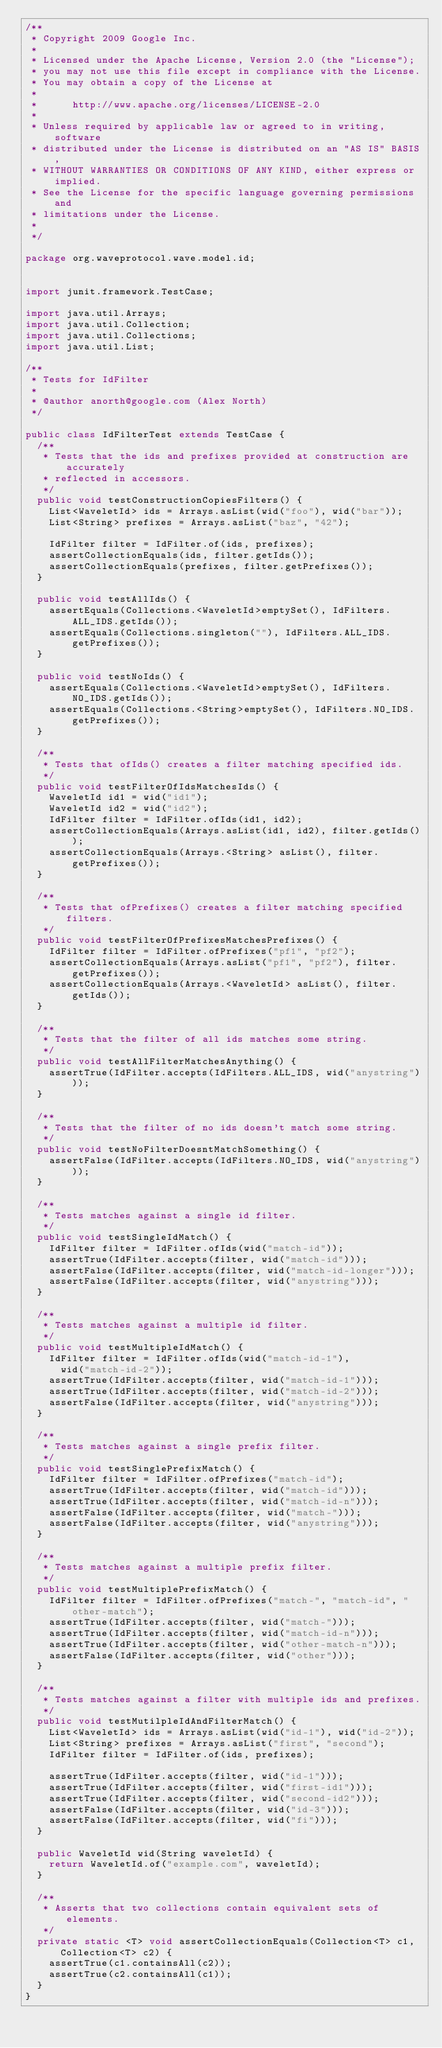<code> <loc_0><loc_0><loc_500><loc_500><_Java_>/**
 * Copyright 2009 Google Inc.
 *
 * Licensed under the Apache License, Version 2.0 (the "License");
 * you may not use this file except in compliance with the License.
 * You may obtain a copy of the License at
 *
 *      http://www.apache.org/licenses/LICENSE-2.0
 *
 * Unless required by applicable law or agreed to in writing, software
 * distributed under the License is distributed on an "AS IS" BASIS,
 * WITHOUT WARRANTIES OR CONDITIONS OF ANY KIND, either express or implied.
 * See the License for the specific language governing permissions and
 * limitations under the License.
 *
 */

package org.waveprotocol.wave.model.id;


import junit.framework.TestCase;

import java.util.Arrays;
import java.util.Collection;
import java.util.Collections;
import java.util.List;

/**
 * Tests for IdFilter
 *
 * @author anorth@google.com (Alex North)
 */

public class IdFilterTest extends TestCase {
  /**
   * Tests that the ids and prefixes provided at construction are accurately
   * reflected in accessors.
   */
  public void testConstructionCopiesFilters() {
    List<WaveletId> ids = Arrays.asList(wid("foo"), wid("bar"));
    List<String> prefixes = Arrays.asList("baz", "42");

    IdFilter filter = IdFilter.of(ids, prefixes);
    assertCollectionEquals(ids, filter.getIds());
    assertCollectionEquals(prefixes, filter.getPrefixes());
  }

  public void testAllIds() {
    assertEquals(Collections.<WaveletId>emptySet(), IdFilters.ALL_IDS.getIds());
    assertEquals(Collections.singleton(""), IdFilters.ALL_IDS.getPrefixes());
  }

  public void testNoIds() {
    assertEquals(Collections.<WaveletId>emptySet(), IdFilters.NO_IDS.getIds());
    assertEquals(Collections.<String>emptySet(), IdFilters.NO_IDS.getPrefixes());
  }

  /**
   * Tests that ofIds() creates a filter matching specified ids.
   */
  public void testFilterOfIdsMatchesIds() {
    WaveletId id1 = wid("id1");
    WaveletId id2 = wid("id2");
    IdFilter filter = IdFilter.ofIds(id1, id2);
    assertCollectionEquals(Arrays.asList(id1, id2), filter.getIds());
    assertCollectionEquals(Arrays.<String> asList(), filter.getPrefixes());
  }

  /**
   * Tests that ofPrefixes() creates a filter matching specified filters.
   */
  public void testFilterOfPrefixesMatchesPrefixes() {
    IdFilter filter = IdFilter.ofPrefixes("pf1", "pf2");
    assertCollectionEquals(Arrays.asList("pf1", "pf2"), filter.getPrefixes());
    assertCollectionEquals(Arrays.<WaveletId> asList(), filter.getIds());
  }

  /**
   * Tests that the filter of all ids matches some string.
   */
  public void testAllFilterMatchesAnything() {
    assertTrue(IdFilter.accepts(IdFilters.ALL_IDS, wid("anystring")));
  }

  /**
   * Tests that the filter of no ids doesn't match some string.
   */
  public void testNoFilterDoesntMatchSomething() {
    assertFalse(IdFilter.accepts(IdFilters.NO_IDS, wid("anystring")));
  }

  /**
   * Tests matches against a single id filter.
   */
  public void testSingleIdMatch() {
    IdFilter filter = IdFilter.ofIds(wid("match-id"));
    assertTrue(IdFilter.accepts(filter, wid("match-id")));
    assertFalse(IdFilter.accepts(filter, wid("match-id-longer")));
    assertFalse(IdFilter.accepts(filter, wid("anystring")));
  }

  /**
   * Tests matches against a multiple id filter.
   */
  public void testMultipleIdMatch() {
    IdFilter filter = IdFilter.ofIds(wid("match-id-1"),
      wid("match-id-2"));
    assertTrue(IdFilter.accepts(filter, wid("match-id-1")));
    assertTrue(IdFilter.accepts(filter, wid("match-id-2")));
    assertFalse(IdFilter.accepts(filter, wid("anystring")));
  }

  /**
   * Tests matches against a single prefix filter.
   */
  public void testSinglePrefixMatch() {
    IdFilter filter = IdFilter.ofPrefixes("match-id");
    assertTrue(IdFilter.accepts(filter, wid("match-id")));
    assertTrue(IdFilter.accepts(filter, wid("match-id-n")));
    assertFalse(IdFilter.accepts(filter, wid("match-")));
    assertFalse(IdFilter.accepts(filter, wid("anystring")));
  }

  /**
   * Tests matches against a multiple prefix filter.
   */
  public void testMultiplePrefixMatch() {
    IdFilter filter = IdFilter.ofPrefixes("match-", "match-id", "other-match");
    assertTrue(IdFilter.accepts(filter, wid("match-")));
    assertTrue(IdFilter.accepts(filter, wid("match-id-n")));
    assertTrue(IdFilter.accepts(filter, wid("other-match-n")));
    assertFalse(IdFilter.accepts(filter, wid("other")));
  }

  /**
   * Tests matches against a filter with multiple ids and prefixes.
   */
  public void testMutilpleIdAndFilterMatch() {
    List<WaveletId> ids = Arrays.asList(wid("id-1"), wid("id-2"));
    List<String> prefixes = Arrays.asList("first", "second");
    IdFilter filter = IdFilter.of(ids, prefixes);

    assertTrue(IdFilter.accepts(filter, wid("id-1")));
    assertTrue(IdFilter.accepts(filter, wid("first-id1")));
    assertTrue(IdFilter.accepts(filter, wid("second-id2")));
    assertFalse(IdFilter.accepts(filter, wid("id-3")));
    assertFalse(IdFilter.accepts(filter, wid("fi")));
  }

  public WaveletId wid(String waveletId) {
    return WaveletId.of("example.com", waveletId);
  }

  /**
   * Asserts that two collections contain equivalent sets of elements.
   */
  private static <T> void assertCollectionEquals(Collection<T> c1, Collection<T> c2) {
    assertTrue(c1.containsAll(c2));
    assertTrue(c2.containsAll(c1));
  }
}
</code> 